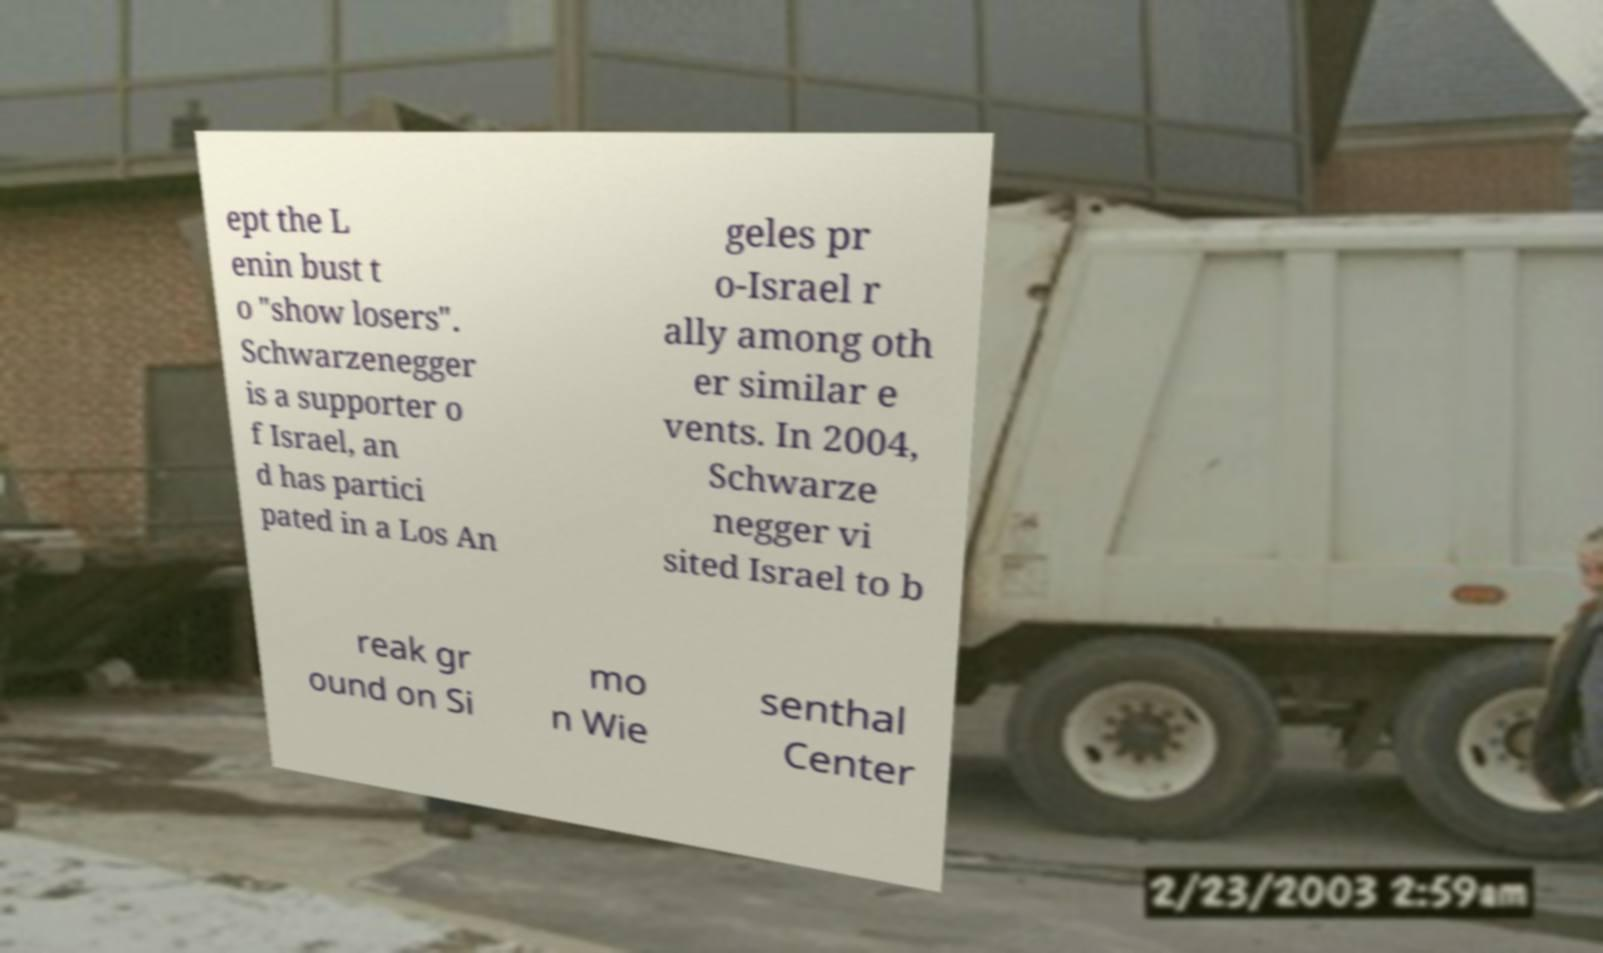Could you assist in decoding the text presented in this image and type it out clearly? ept the L enin bust t o "show losers". Schwarzenegger is a supporter o f Israel, an d has partici pated in a Los An geles pr o-Israel r ally among oth er similar e vents. In 2004, Schwarze negger vi sited Israel to b reak gr ound on Si mo n Wie senthal Center 